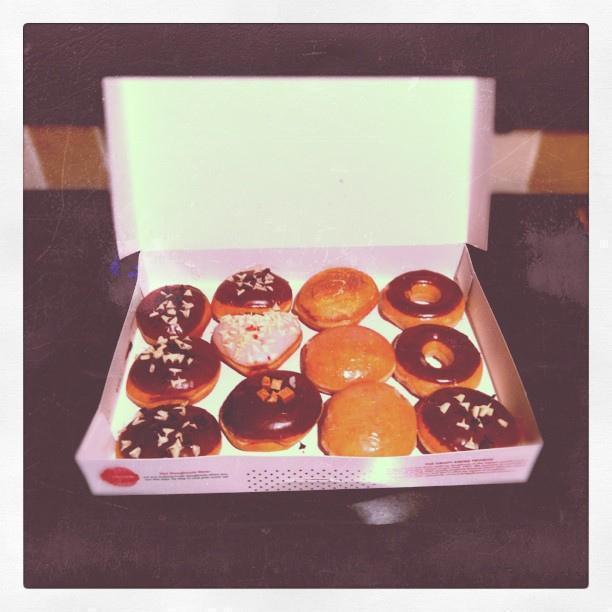What is the box made of?
Answer the question by selecting the correct answer among the 4 following choices.
Options: Glass, steel, paper, plastic. Paper. 